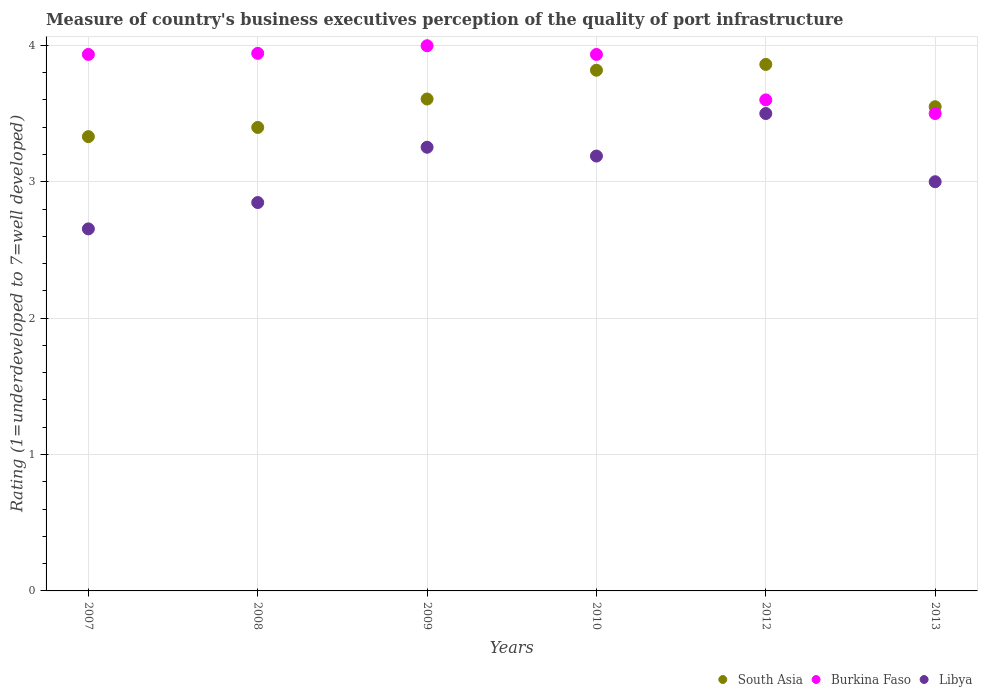What is the ratings of the quality of port infrastructure in Libya in 2009?
Provide a short and direct response. 3.25. Across all years, what is the maximum ratings of the quality of port infrastructure in Burkina Faso?
Offer a very short reply. 4. Across all years, what is the minimum ratings of the quality of port infrastructure in Libya?
Provide a short and direct response. 2.65. In which year was the ratings of the quality of port infrastructure in Burkina Faso maximum?
Offer a terse response. 2009. In which year was the ratings of the quality of port infrastructure in Burkina Faso minimum?
Offer a terse response. 2013. What is the total ratings of the quality of port infrastructure in South Asia in the graph?
Provide a succinct answer. 21.56. What is the difference between the ratings of the quality of port infrastructure in Libya in 2008 and that in 2010?
Provide a short and direct response. -0.34. What is the difference between the ratings of the quality of port infrastructure in South Asia in 2007 and the ratings of the quality of port infrastructure in Burkina Faso in 2008?
Your answer should be very brief. -0.61. What is the average ratings of the quality of port infrastructure in South Asia per year?
Your answer should be very brief. 3.59. In the year 2009, what is the difference between the ratings of the quality of port infrastructure in Libya and ratings of the quality of port infrastructure in South Asia?
Provide a short and direct response. -0.35. In how many years, is the ratings of the quality of port infrastructure in Burkina Faso greater than 1?
Your answer should be very brief. 6. What is the ratio of the ratings of the quality of port infrastructure in Burkina Faso in 2008 to that in 2012?
Provide a succinct answer. 1.09. Is the ratings of the quality of port infrastructure in Libya in 2008 less than that in 2010?
Provide a short and direct response. Yes. Is the difference between the ratings of the quality of port infrastructure in Libya in 2007 and 2012 greater than the difference between the ratings of the quality of port infrastructure in South Asia in 2007 and 2012?
Give a very brief answer. No. What is the difference between the highest and the second highest ratings of the quality of port infrastructure in Burkina Faso?
Offer a terse response. 0.06. What is the difference between the highest and the lowest ratings of the quality of port infrastructure in South Asia?
Ensure brevity in your answer.  0.53. In how many years, is the ratings of the quality of port infrastructure in Libya greater than the average ratings of the quality of port infrastructure in Libya taken over all years?
Ensure brevity in your answer.  3. Is it the case that in every year, the sum of the ratings of the quality of port infrastructure in South Asia and ratings of the quality of port infrastructure in Libya  is greater than the ratings of the quality of port infrastructure in Burkina Faso?
Your answer should be very brief. Yes. Does the ratings of the quality of port infrastructure in Libya monotonically increase over the years?
Make the answer very short. No. Is the ratings of the quality of port infrastructure in Burkina Faso strictly greater than the ratings of the quality of port infrastructure in Libya over the years?
Your answer should be very brief. Yes. Is the ratings of the quality of port infrastructure in Libya strictly less than the ratings of the quality of port infrastructure in Burkina Faso over the years?
Your response must be concise. Yes. What is the difference between two consecutive major ticks on the Y-axis?
Keep it short and to the point. 1. Does the graph contain any zero values?
Provide a succinct answer. No. Does the graph contain grids?
Make the answer very short. Yes. How many legend labels are there?
Give a very brief answer. 3. What is the title of the graph?
Provide a succinct answer. Measure of country's business executives perception of the quality of port infrastructure. Does "Peru" appear as one of the legend labels in the graph?
Keep it short and to the point. No. What is the label or title of the X-axis?
Your answer should be compact. Years. What is the label or title of the Y-axis?
Offer a terse response. Rating (1=underdeveloped to 7=well developed). What is the Rating (1=underdeveloped to 7=well developed) in South Asia in 2007?
Give a very brief answer. 3.33. What is the Rating (1=underdeveloped to 7=well developed) in Burkina Faso in 2007?
Offer a terse response. 3.93. What is the Rating (1=underdeveloped to 7=well developed) in Libya in 2007?
Keep it short and to the point. 2.65. What is the Rating (1=underdeveloped to 7=well developed) in South Asia in 2008?
Give a very brief answer. 3.4. What is the Rating (1=underdeveloped to 7=well developed) of Burkina Faso in 2008?
Ensure brevity in your answer.  3.94. What is the Rating (1=underdeveloped to 7=well developed) in Libya in 2008?
Make the answer very short. 2.85. What is the Rating (1=underdeveloped to 7=well developed) of South Asia in 2009?
Make the answer very short. 3.61. What is the Rating (1=underdeveloped to 7=well developed) of Burkina Faso in 2009?
Make the answer very short. 4. What is the Rating (1=underdeveloped to 7=well developed) of Libya in 2009?
Offer a terse response. 3.25. What is the Rating (1=underdeveloped to 7=well developed) in South Asia in 2010?
Keep it short and to the point. 3.82. What is the Rating (1=underdeveloped to 7=well developed) in Burkina Faso in 2010?
Make the answer very short. 3.93. What is the Rating (1=underdeveloped to 7=well developed) in Libya in 2010?
Your answer should be compact. 3.19. What is the Rating (1=underdeveloped to 7=well developed) of South Asia in 2012?
Provide a short and direct response. 3.86. What is the Rating (1=underdeveloped to 7=well developed) of Burkina Faso in 2012?
Your response must be concise. 3.6. What is the Rating (1=underdeveloped to 7=well developed) of Libya in 2012?
Give a very brief answer. 3.5. What is the Rating (1=underdeveloped to 7=well developed) in South Asia in 2013?
Keep it short and to the point. 3.55. What is the Rating (1=underdeveloped to 7=well developed) of Libya in 2013?
Offer a very short reply. 3. Across all years, what is the maximum Rating (1=underdeveloped to 7=well developed) in South Asia?
Ensure brevity in your answer.  3.86. Across all years, what is the maximum Rating (1=underdeveloped to 7=well developed) in Burkina Faso?
Ensure brevity in your answer.  4. Across all years, what is the maximum Rating (1=underdeveloped to 7=well developed) in Libya?
Ensure brevity in your answer.  3.5. Across all years, what is the minimum Rating (1=underdeveloped to 7=well developed) of South Asia?
Make the answer very short. 3.33. Across all years, what is the minimum Rating (1=underdeveloped to 7=well developed) in Burkina Faso?
Make the answer very short. 3.5. Across all years, what is the minimum Rating (1=underdeveloped to 7=well developed) in Libya?
Give a very brief answer. 2.65. What is the total Rating (1=underdeveloped to 7=well developed) in South Asia in the graph?
Make the answer very short. 21.56. What is the total Rating (1=underdeveloped to 7=well developed) of Burkina Faso in the graph?
Keep it short and to the point. 22.9. What is the total Rating (1=underdeveloped to 7=well developed) of Libya in the graph?
Your answer should be compact. 18.44. What is the difference between the Rating (1=underdeveloped to 7=well developed) of South Asia in 2007 and that in 2008?
Give a very brief answer. -0.07. What is the difference between the Rating (1=underdeveloped to 7=well developed) of Burkina Faso in 2007 and that in 2008?
Your response must be concise. -0.01. What is the difference between the Rating (1=underdeveloped to 7=well developed) of Libya in 2007 and that in 2008?
Your answer should be very brief. -0.19. What is the difference between the Rating (1=underdeveloped to 7=well developed) in South Asia in 2007 and that in 2009?
Your response must be concise. -0.28. What is the difference between the Rating (1=underdeveloped to 7=well developed) of Burkina Faso in 2007 and that in 2009?
Offer a very short reply. -0.06. What is the difference between the Rating (1=underdeveloped to 7=well developed) in Libya in 2007 and that in 2009?
Provide a succinct answer. -0.6. What is the difference between the Rating (1=underdeveloped to 7=well developed) of South Asia in 2007 and that in 2010?
Make the answer very short. -0.49. What is the difference between the Rating (1=underdeveloped to 7=well developed) in Libya in 2007 and that in 2010?
Keep it short and to the point. -0.53. What is the difference between the Rating (1=underdeveloped to 7=well developed) of South Asia in 2007 and that in 2012?
Provide a short and direct response. -0.53. What is the difference between the Rating (1=underdeveloped to 7=well developed) of Burkina Faso in 2007 and that in 2012?
Your response must be concise. 0.33. What is the difference between the Rating (1=underdeveloped to 7=well developed) in Libya in 2007 and that in 2012?
Ensure brevity in your answer.  -0.85. What is the difference between the Rating (1=underdeveloped to 7=well developed) of South Asia in 2007 and that in 2013?
Your response must be concise. -0.22. What is the difference between the Rating (1=underdeveloped to 7=well developed) in Burkina Faso in 2007 and that in 2013?
Keep it short and to the point. 0.43. What is the difference between the Rating (1=underdeveloped to 7=well developed) in Libya in 2007 and that in 2013?
Keep it short and to the point. -0.35. What is the difference between the Rating (1=underdeveloped to 7=well developed) in South Asia in 2008 and that in 2009?
Provide a succinct answer. -0.21. What is the difference between the Rating (1=underdeveloped to 7=well developed) in Burkina Faso in 2008 and that in 2009?
Your answer should be compact. -0.06. What is the difference between the Rating (1=underdeveloped to 7=well developed) of Libya in 2008 and that in 2009?
Provide a succinct answer. -0.41. What is the difference between the Rating (1=underdeveloped to 7=well developed) in South Asia in 2008 and that in 2010?
Provide a short and direct response. -0.42. What is the difference between the Rating (1=underdeveloped to 7=well developed) in Burkina Faso in 2008 and that in 2010?
Your answer should be compact. 0.01. What is the difference between the Rating (1=underdeveloped to 7=well developed) of Libya in 2008 and that in 2010?
Your answer should be compact. -0.34. What is the difference between the Rating (1=underdeveloped to 7=well developed) of South Asia in 2008 and that in 2012?
Your answer should be compact. -0.46. What is the difference between the Rating (1=underdeveloped to 7=well developed) in Burkina Faso in 2008 and that in 2012?
Ensure brevity in your answer.  0.34. What is the difference between the Rating (1=underdeveloped to 7=well developed) of Libya in 2008 and that in 2012?
Offer a very short reply. -0.65. What is the difference between the Rating (1=underdeveloped to 7=well developed) in South Asia in 2008 and that in 2013?
Make the answer very short. -0.15. What is the difference between the Rating (1=underdeveloped to 7=well developed) in Burkina Faso in 2008 and that in 2013?
Keep it short and to the point. 0.44. What is the difference between the Rating (1=underdeveloped to 7=well developed) of Libya in 2008 and that in 2013?
Make the answer very short. -0.15. What is the difference between the Rating (1=underdeveloped to 7=well developed) in South Asia in 2009 and that in 2010?
Ensure brevity in your answer.  -0.21. What is the difference between the Rating (1=underdeveloped to 7=well developed) in Burkina Faso in 2009 and that in 2010?
Ensure brevity in your answer.  0.06. What is the difference between the Rating (1=underdeveloped to 7=well developed) of Libya in 2009 and that in 2010?
Provide a short and direct response. 0.06. What is the difference between the Rating (1=underdeveloped to 7=well developed) in South Asia in 2009 and that in 2012?
Your response must be concise. -0.25. What is the difference between the Rating (1=underdeveloped to 7=well developed) in Burkina Faso in 2009 and that in 2012?
Offer a very short reply. 0.4. What is the difference between the Rating (1=underdeveloped to 7=well developed) in Libya in 2009 and that in 2012?
Your answer should be very brief. -0.25. What is the difference between the Rating (1=underdeveloped to 7=well developed) in South Asia in 2009 and that in 2013?
Your response must be concise. 0.06. What is the difference between the Rating (1=underdeveloped to 7=well developed) in Burkina Faso in 2009 and that in 2013?
Provide a short and direct response. 0.5. What is the difference between the Rating (1=underdeveloped to 7=well developed) of Libya in 2009 and that in 2013?
Provide a short and direct response. 0.25. What is the difference between the Rating (1=underdeveloped to 7=well developed) in South Asia in 2010 and that in 2012?
Ensure brevity in your answer.  -0.04. What is the difference between the Rating (1=underdeveloped to 7=well developed) of Burkina Faso in 2010 and that in 2012?
Provide a succinct answer. 0.33. What is the difference between the Rating (1=underdeveloped to 7=well developed) of Libya in 2010 and that in 2012?
Give a very brief answer. -0.31. What is the difference between the Rating (1=underdeveloped to 7=well developed) in South Asia in 2010 and that in 2013?
Offer a terse response. 0.27. What is the difference between the Rating (1=underdeveloped to 7=well developed) of Burkina Faso in 2010 and that in 2013?
Provide a short and direct response. 0.43. What is the difference between the Rating (1=underdeveloped to 7=well developed) of Libya in 2010 and that in 2013?
Offer a terse response. 0.19. What is the difference between the Rating (1=underdeveloped to 7=well developed) in South Asia in 2012 and that in 2013?
Your response must be concise. 0.31. What is the difference between the Rating (1=underdeveloped to 7=well developed) in South Asia in 2007 and the Rating (1=underdeveloped to 7=well developed) in Burkina Faso in 2008?
Your response must be concise. -0.61. What is the difference between the Rating (1=underdeveloped to 7=well developed) of South Asia in 2007 and the Rating (1=underdeveloped to 7=well developed) of Libya in 2008?
Your response must be concise. 0.48. What is the difference between the Rating (1=underdeveloped to 7=well developed) of Burkina Faso in 2007 and the Rating (1=underdeveloped to 7=well developed) of Libya in 2008?
Offer a terse response. 1.09. What is the difference between the Rating (1=underdeveloped to 7=well developed) of South Asia in 2007 and the Rating (1=underdeveloped to 7=well developed) of Burkina Faso in 2009?
Provide a short and direct response. -0.67. What is the difference between the Rating (1=underdeveloped to 7=well developed) of South Asia in 2007 and the Rating (1=underdeveloped to 7=well developed) of Libya in 2009?
Keep it short and to the point. 0.08. What is the difference between the Rating (1=underdeveloped to 7=well developed) in Burkina Faso in 2007 and the Rating (1=underdeveloped to 7=well developed) in Libya in 2009?
Your answer should be very brief. 0.68. What is the difference between the Rating (1=underdeveloped to 7=well developed) of South Asia in 2007 and the Rating (1=underdeveloped to 7=well developed) of Burkina Faso in 2010?
Provide a short and direct response. -0.6. What is the difference between the Rating (1=underdeveloped to 7=well developed) of South Asia in 2007 and the Rating (1=underdeveloped to 7=well developed) of Libya in 2010?
Ensure brevity in your answer.  0.14. What is the difference between the Rating (1=underdeveloped to 7=well developed) in Burkina Faso in 2007 and the Rating (1=underdeveloped to 7=well developed) in Libya in 2010?
Your answer should be compact. 0.75. What is the difference between the Rating (1=underdeveloped to 7=well developed) of South Asia in 2007 and the Rating (1=underdeveloped to 7=well developed) of Burkina Faso in 2012?
Keep it short and to the point. -0.27. What is the difference between the Rating (1=underdeveloped to 7=well developed) in South Asia in 2007 and the Rating (1=underdeveloped to 7=well developed) in Libya in 2012?
Provide a short and direct response. -0.17. What is the difference between the Rating (1=underdeveloped to 7=well developed) in Burkina Faso in 2007 and the Rating (1=underdeveloped to 7=well developed) in Libya in 2012?
Give a very brief answer. 0.43. What is the difference between the Rating (1=underdeveloped to 7=well developed) in South Asia in 2007 and the Rating (1=underdeveloped to 7=well developed) in Burkina Faso in 2013?
Give a very brief answer. -0.17. What is the difference between the Rating (1=underdeveloped to 7=well developed) of South Asia in 2007 and the Rating (1=underdeveloped to 7=well developed) of Libya in 2013?
Offer a very short reply. 0.33. What is the difference between the Rating (1=underdeveloped to 7=well developed) in Burkina Faso in 2007 and the Rating (1=underdeveloped to 7=well developed) in Libya in 2013?
Offer a very short reply. 0.93. What is the difference between the Rating (1=underdeveloped to 7=well developed) of South Asia in 2008 and the Rating (1=underdeveloped to 7=well developed) of Burkina Faso in 2009?
Keep it short and to the point. -0.6. What is the difference between the Rating (1=underdeveloped to 7=well developed) in South Asia in 2008 and the Rating (1=underdeveloped to 7=well developed) in Libya in 2009?
Provide a short and direct response. 0.15. What is the difference between the Rating (1=underdeveloped to 7=well developed) of Burkina Faso in 2008 and the Rating (1=underdeveloped to 7=well developed) of Libya in 2009?
Make the answer very short. 0.69. What is the difference between the Rating (1=underdeveloped to 7=well developed) in South Asia in 2008 and the Rating (1=underdeveloped to 7=well developed) in Burkina Faso in 2010?
Provide a short and direct response. -0.54. What is the difference between the Rating (1=underdeveloped to 7=well developed) in South Asia in 2008 and the Rating (1=underdeveloped to 7=well developed) in Libya in 2010?
Your answer should be compact. 0.21. What is the difference between the Rating (1=underdeveloped to 7=well developed) of Burkina Faso in 2008 and the Rating (1=underdeveloped to 7=well developed) of Libya in 2010?
Ensure brevity in your answer.  0.75. What is the difference between the Rating (1=underdeveloped to 7=well developed) of South Asia in 2008 and the Rating (1=underdeveloped to 7=well developed) of Burkina Faso in 2012?
Make the answer very short. -0.2. What is the difference between the Rating (1=underdeveloped to 7=well developed) in South Asia in 2008 and the Rating (1=underdeveloped to 7=well developed) in Libya in 2012?
Keep it short and to the point. -0.1. What is the difference between the Rating (1=underdeveloped to 7=well developed) in Burkina Faso in 2008 and the Rating (1=underdeveloped to 7=well developed) in Libya in 2012?
Provide a succinct answer. 0.44. What is the difference between the Rating (1=underdeveloped to 7=well developed) in South Asia in 2008 and the Rating (1=underdeveloped to 7=well developed) in Burkina Faso in 2013?
Provide a succinct answer. -0.1. What is the difference between the Rating (1=underdeveloped to 7=well developed) in South Asia in 2008 and the Rating (1=underdeveloped to 7=well developed) in Libya in 2013?
Ensure brevity in your answer.  0.4. What is the difference between the Rating (1=underdeveloped to 7=well developed) in South Asia in 2009 and the Rating (1=underdeveloped to 7=well developed) in Burkina Faso in 2010?
Ensure brevity in your answer.  -0.33. What is the difference between the Rating (1=underdeveloped to 7=well developed) in South Asia in 2009 and the Rating (1=underdeveloped to 7=well developed) in Libya in 2010?
Your answer should be very brief. 0.42. What is the difference between the Rating (1=underdeveloped to 7=well developed) of Burkina Faso in 2009 and the Rating (1=underdeveloped to 7=well developed) of Libya in 2010?
Offer a terse response. 0.81. What is the difference between the Rating (1=underdeveloped to 7=well developed) of South Asia in 2009 and the Rating (1=underdeveloped to 7=well developed) of Burkina Faso in 2012?
Make the answer very short. 0.01. What is the difference between the Rating (1=underdeveloped to 7=well developed) in South Asia in 2009 and the Rating (1=underdeveloped to 7=well developed) in Libya in 2012?
Provide a succinct answer. 0.11. What is the difference between the Rating (1=underdeveloped to 7=well developed) of Burkina Faso in 2009 and the Rating (1=underdeveloped to 7=well developed) of Libya in 2012?
Give a very brief answer. 0.5. What is the difference between the Rating (1=underdeveloped to 7=well developed) in South Asia in 2009 and the Rating (1=underdeveloped to 7=well developed) in Burkina Faso in 2013?
Your response must be concise. 0.11. What is the difference between the Rating (1=underdeveloped to 7=well developed) in South Asia in 2009 and the Rating (1=underdeveloped to 7=well developed) in Libya in 2013?
Provide a succinct answer. 0.61. What is the difference between the Rating (1=underdeveloped to 7=well developed) of Burkina Faso in 2009 and the Rating (1=underdeveloped to 7=well developed) of Libya in 2013?
Provide a short and direct response. 1. What is the difference between the Rating (1=underdeveloped to 7=well developed) of South Asia in 2010 and the Rating (1=underdeveloped to 7=well developed) of Burkina Faso in 2012?
Your answer should be very brief. 0.22. What is the difference between the Rating (1=underdeveloped to 7=well developed) of South Asia in 2010 and the Rating (1=underdeveloped to 7=well developed) of Libya in 2012?
Your answer should be very brief. 0.32. What is the difference between the Rating (1=underdeveloped to 7=well developed) of Burkina Faso in 2010 and the Rating (1=underdeveloped to 7=well developed) of Libya in 2012?
Provide a succinct answer. 0.43. What is the difference between the Rating (1=underdeveloped to 7=well developed) in South Asia in 2010 and the Rating (1=underdeveloped to 7=well developed) in Burkina Faso in 2013?
Keep it short and to the point. 0.32. What is the difference between the Rating (1=underdeveloped to 7=well developed) in South Asia in 2010 and the Rating (1=underdeveloped to 7=well developed) in Libya in 2013?
Your answer should be very brief. 0.82. What is the difference between the Rating (1=underdeveloped to 7=well developed) of Burkina Faso in 2010 and the Rating (1=underdeveloped to 7=well developed) of Libya in 2013?
Provide a short and direct response. 0.93. What is the difference between the Rating (1=underdeveloped to 7=well developed) in South Asia in 2012 and the Rating (1=underdeveloped to 7=well developed) in Burkina Faso in 2013?
Keep it short and to the point. 0.36. What is the difference between the Rating (1=underdeveloped to 7=well developed) in South Asia in 2012 and the Rating (1=underdeveloped to 7=well developed) in Libya in 2013?
Make the answer very short. 0.86. What is the average Rating (1=underdeveloped to 7=well developed) of South Asia per year?
Offer a terse response. 3.59. What is the average Rating (1=underdeveloped to 7=well developed) of Burkina Faso per year?
Give a very brief answer. 3.82. What is the average Rating (1=underdeveloped to 7=well developed) in Libya per year?
Give a very brief answer. 3.07. In the year 2007, what is the difference between the Rating (1=underdeveloped to 7=well developed) in South Asia and Rating (1=underdeveloped to 7=well developed) in Burkina Faso?
Make the answer very short. -0.6. In the year 2007, what is the difference between the Rating (1=underdeveloped to 7=well developed) in South Asia and Rating (1=underdeveloped to 7=well developed) in Libya?
Provide a succinct answer. 0.68. In the year 2007, what is the difference between the Rating (1=underdeveloped to 7=well developed) of Burkina Faso and Rating (1=underdeveloped to 7=well developed) of Libya?
Offer a very short reply. 1.28. In the year 2008, what is the difference between the Rating (1=underdeveloped to 7=well developed) in South Asia and Rating (1=underdeveloped to 7=well developed) in Burkina Faso?
Keep it short and to the point. -0.54. In the year 2008, what is the difference between the Rating (1=underdeveloped to 7=well developed) of South Asia and Rating (1=underdeveloped to 7=well developed) of Libya?
Your answer should be compact. 0.55. In the year 2008, what is the difference between the Rating (1=underdeveloped to 7=well developed) in Burkina Faso and Rating (1=underdeveloped to 7=well developed) in Libya?
Your answer should be very brief. 1.09. In the year 2009, what is the difference between the Rating (1=underdeveloped to 7=well developed) of South Asia and Rating (1=underdeveloped to 7=well developed) of Burkina Faso?
Make the answer very short. -0.39. In the year 2009, what is the difference between the Rating (1=underdeveloped to 7=well developed) in South Asia and Rating (1=underdeveloped to 7=well developed) in Libya?
Keep it short and to the point. 0.35. In the year 2009, what is the difference between the Rating (1=underdeveloped to 7=well developed) in Burkina Faso and Rating (1=underdeveloped to 7=well developed) in Libya?
Your answer should be very brief. 0.74. In the year 2010, what is the difference between the Rating (1=underdeveloped to 7=well developed) in South Asia and Rating (1=underdeveloped to 7=well developed) in Burkina Faso?
Your answer should be very brief. -0.12. In the year 2010, what is the difference between the Rating (1=underdeveloped to 7=well developed) in South Asia and Rating (1=underdeveloped to 7=well developed) in Libya?
Keep it short and to the point. 0.63. In the year 2010, what is the difference between the Rating (1=underdeveloped to 7=well developed) of Burkina Faso and Rating (1=underdeveloped to 7=well developed) of Libya?
Your answer should be compact. 0.74. In the year 2012, what is the difference between the Rating (1=underdeveloped to 7=well developed) of South Asia and Rating (1=underdeveloped to 7=well developed) of Burkina Faso?
Keep it short and to the point. 0.26. In the year 2012, what is the difference between the Rating (1=underdeveloped to 7=well developed) in South Asia and Rating (1=underdeveloped to 7=well developed) in Libya?
Offer a terse response. 0.36. In the year 2013, what is the difference between the Rating (1=underdeveloped to 7=well developed) in South Asia and Rating (1=underdeveloped to 7=well developed) in Burkina Faso?
Ensure brevity in your answer.  0.05. In the year 2013, what is the difference between the Rating (1=underdeveloped to 7=well developed) of South Asia and Rating (1=underdeveloped to 7=well developed) of Libya?
Provide a succinct answer. 0.55. What is the ratio of the Rating (1=underdeveloped to 7=well developed) in South Asia in 2007 to that in 2008?
Offer a very short reply. 0.98. What is the ratio of the Rating (1=underdeveloped to 7=well developed) in Burkina Faso in 2007 to that in 2008?
Your answer should be compact. 1. What is the ratio of the Rating (1=underdeveloped to 7=well developed) in Libya in 2007 to that in 2008?
Ensure brevity in your answer.  0.93. What is the ratio of the Rating (1=underdeveloped to 7=well developed) in South Asia in 2007 to that in 2009?
Your answer should be compact. 0.92. What is the ratio of the Rating (1=underdeveloped to 7=well developed) of Burkina Faso in 2007 to that in 2009?
Offer a terse response. 0.98. What is the ratio of the Rating (1=underdeveloped to 7=well developed) in Libya in 2007 to that in 2009?
Offer a very short reply. 0.82. What is the ratio of the Rating (1=underdeveloped to 7=well developed) of South Asia in 2007 to that in 2010?
Make the answer very short. 0.87. What is the ratio of the Rating (1=underdeveloped to 7=well developed) of Libya in 2007 to that in 2010?
Your response must be concise. 0.83. What is the ratio of the Rating (1=underdeveloped to 7=well developed) in South Asia in 2007 to that in 2012?
Make the answer very short. 0.86. What is the ratio of the Rating (1=underdeveloped to 7=well developed) of Burkina Faso in 2007 to that in 2012?
Your response must be concise. 1.09. What is the ratio of the Rating (1=underdeveloped to 7=well developed) in Libya in 2007 to that in 2012?
Your answer should be very brief. 0.76. What is the ratio of the Rating (1=underdeveloped to 7=well developed) of South Asia in 2007 to that in 2013?
Make the answer very short. 0.94. What is the ratio of the Rating (1=underdeveloped to 7=well developed) in Burkina Faso in 2007 to that in 2013?
Make the answer very short. 1.12. What is the ratio of the Rating (1=underdeveloped to 7=well developed) in Libya in 2007 to that in 2013?
Your answer should be compact. 0.88. What is the ratio of the Rating (1=underdeveloped to 7=well developed) of South Asia in 2008 to that in 2009?
Ensure brevity in your answer.  0.94. What is the ratio of the Rating (1=underdeveloped to 7=well developed) of Libya in 2008 to that in 2009?
Your response must be concise. 0.88. What is the ratio of the Rating (1=underdeveloped to 7=well developed) in South Asia in 2008 to that in 2010?
Provide a succinct answer. 0.89. What is the ratio of the Rating (1=underdeveloped to 7=well developed) of Burkina Faso in 2008 to that in 2010?
Give a very brief answer. 1. What is the ratio of the Rating (1=underdeveloped to 7=well developed) in Libya in 2008 to that in 2010?
Ensure brevity in your answer.  0.89. What is the ratio of the Rating (1=underdeveloped to 7=well developed) of South Asia in 2008 to that in 2012?
Give a very brief answer. 0.88. What is the ratio of the Rating (1=underdeveloped to 7=well developed) of Burkina Faso in 2008 to that in 2012?
Offer a very short reply. 1.09. What is the ratio of the Rating (1=underdeveloped to 7=well developed) of Libya in 2008 to that in 2012?
Your response must be concise. 0.81. What is the ratio of the Rating (1=underdeveloped to 7=well developed) in South Asia in 2008 to that in 2013?
Provide a succinct answer. 0.96. What is the ratio of the Rating (1=underdeveloped to 7=well developed) in Burkina Faso in 2008 to that in 2013?
Provide a short and direct response. 1.13. What is the ratio of the Rating (1=underdeveloped to 7=well developed) in Libya in 2008 to that in 2013?
Your response must be concise. 0.95. What is the ratio of the Rating (1=underdeveloped to 7=well developed) in South Asia in 2009 to that in 2010?
Provide a succinct answer. 0.94. What is the ratio of the Rating (1=underdeveloped to 7=well developed) in Burkina Faso in 2009 to that in 2010?
Your response must be concise. 1.02. What is the ratio of the Rating (1=underdeveloped to 7=well developed) in Libya in 2009 to that in 2010?
Make the answer very short. 1.02. What is the ratio of the Rating (1=underdeveloped to 7=well developed) in South Asia in 2009 to that in 2012?
Provide a short and direct response. 0.93. What is the ratio of the Rating (1=underdeveloped to 7=well developed) in Burkina Faso in 2009 to that in 2012?
Make the answer very short. 1.11. What is the ratio of the Rating (1=underdeveloped to 7=well developed) of Libya in 2009 to that in 2012?
Provide a short and direct response. 0.93. What is the ratio of the Rating (1=underdeveloped to 7=well developed) in South Asia in 2009 to that in 2013?
Offer a terse response. 1.02. What is the ratio of the Rating (1=underdeveloped to 7=well developed) of Burkina Faso in 2009 to that in 2013?
Keep it short and to the point. 1.14. What is the ratio of the Rating (1=underdeveloped to 7=well developed) of Libya in 2009 to that in 2013?
Your response must be concise. 1.08. What is the ratio of the Rating (1=underdeveloped to 7=well developed) of Burkina Faso in 2010 to that in 2012?
Make the answer very short. 1.09. What is the ratio of the Rating (1=underdeveloped to 7=well developed) in Libya in 2010 to that in 2012?
Offer a terse response. 0.91. What is the ratio of the Rating (1=underdeveloped to 7=well developed) in South Asia in 2010 to that in 2013?
Make the answer very short. 1.08. What is the ratio of the Rating (1=underdeveloped to 7=well developed) in Burkina Faso in 2010 to that in 2013?
Your answer should be compact. 1.12. What is the ratio of the Rating (1=underdeveloped to 7=well developed) of Libya in 2010 to that in 2013?
Your answer should be very brief. 1.06. What is the ratio of the Rating (1=underdeveloped to 7=well developed) of South Asia in 2012 to that in 2013?
Provide a short and direct response. 1.09. What is the ratio of the Rating (1=underdeveloped to 7=well developed) of Burkina Faso in 2012 to that in 2013?
Your answer should be very brief. 1.03. What is the ratio of the Rating (1=underdeveloped to 7=well developed) of Libya in 2012 to that in 2013?
Give a very brief answer. 1.17. What is the difference between the highest and the second highest Rating (1=underdeveloped to 7=well developed) of South Asia?
Your answer should be very brief. 0.04. What is the difference between the highest and the second highest Rating (1=underdeveloped to 7=well developed) in Burkina Faso?
Make the answer very short. 0.06. What is the difference between the highest and the second highest Rating (1=underdeveloped to 7=well developed) of Libya?
Provide a short and direct response. 0.25. What is the difference between the highest and the lowest Rating (1=underdeveloped to 7=well developed) of South Asia?
Your answer should be very brief. 0.53. What is the difference between the highest and the lowest Rating (1=underdeveloped to 7=well developed) of Burkina Faso?
Offer a terse response. 0.5. What is the difference between the highest and the lowest Rating (1=underdeveloped to 7=well developed) in Libya?
Provide a succinct answer. 0.85. 